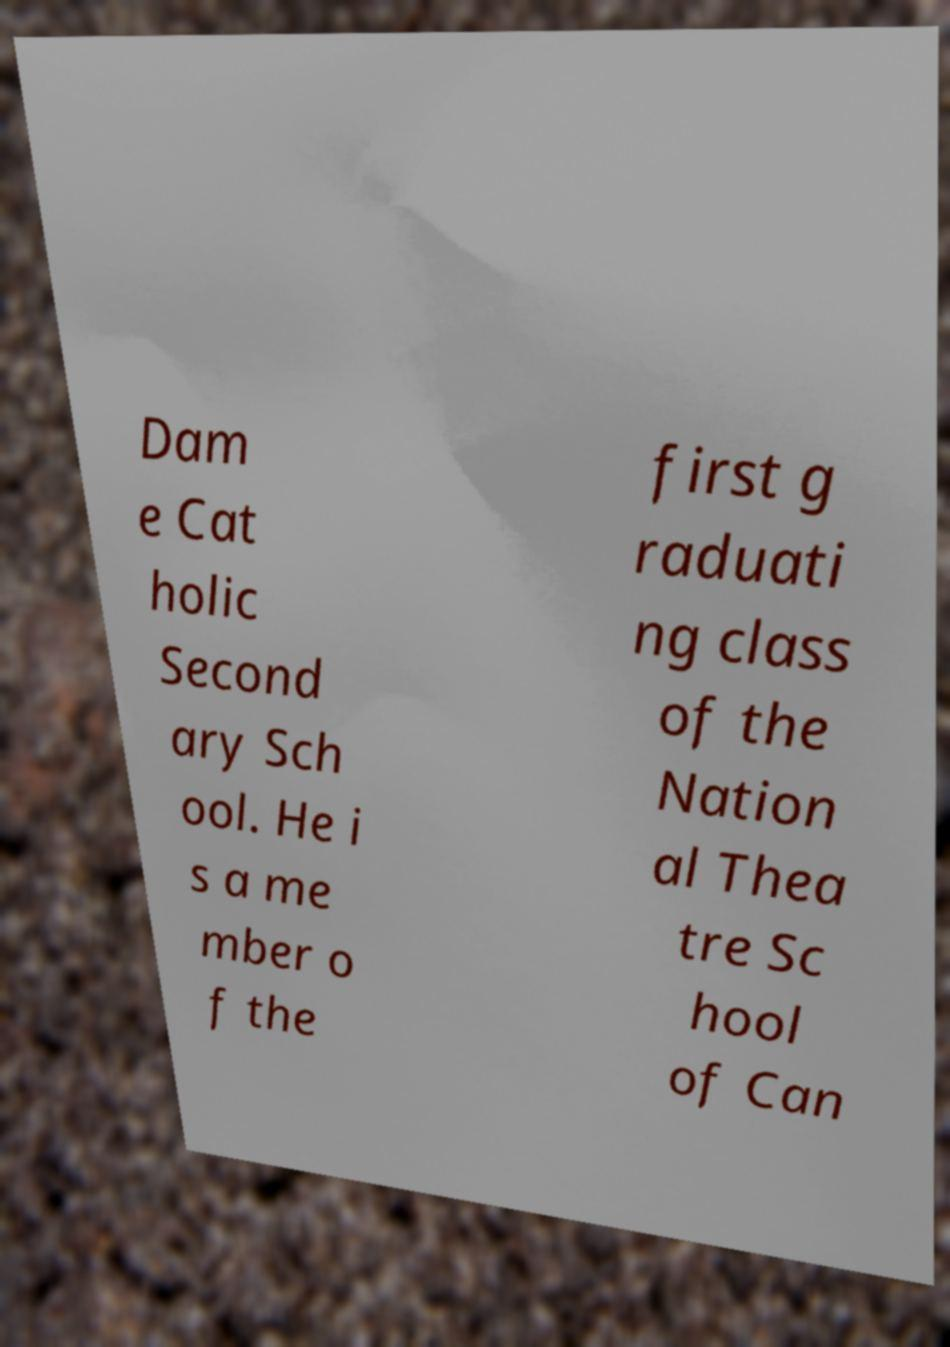For documentation purposes, I need the text within this image transcribed. Could you provide that? Dam e Cat holic Second ary Sch ool. He i s a me mber o f the first g raduati ng class of the Nation al Thea tre Sc hool of Can 